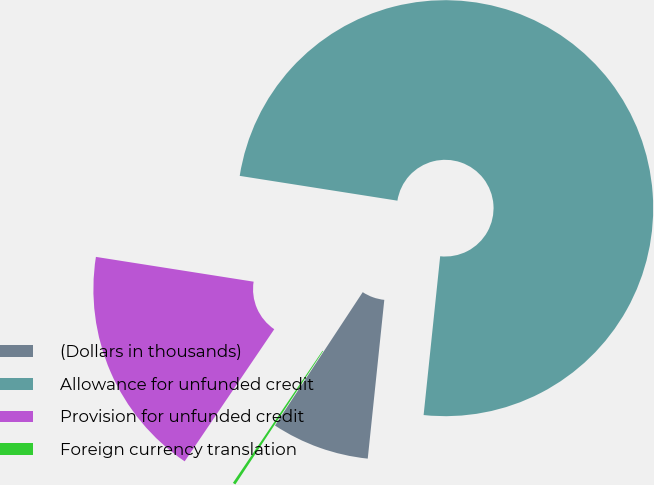<chart> <loc_0><loc_0><loc_500><loc_500><pie_chart><fcel>(Dollars in thousands)<fcel>Allowance for unfunded credit<fcel>Provision for unfunded credit<fcel>Foreign currency translation<nl><fcel>7.61%<fcel>74.18%<fcel>18.0%<fcel>0.22%<nl></chart> 